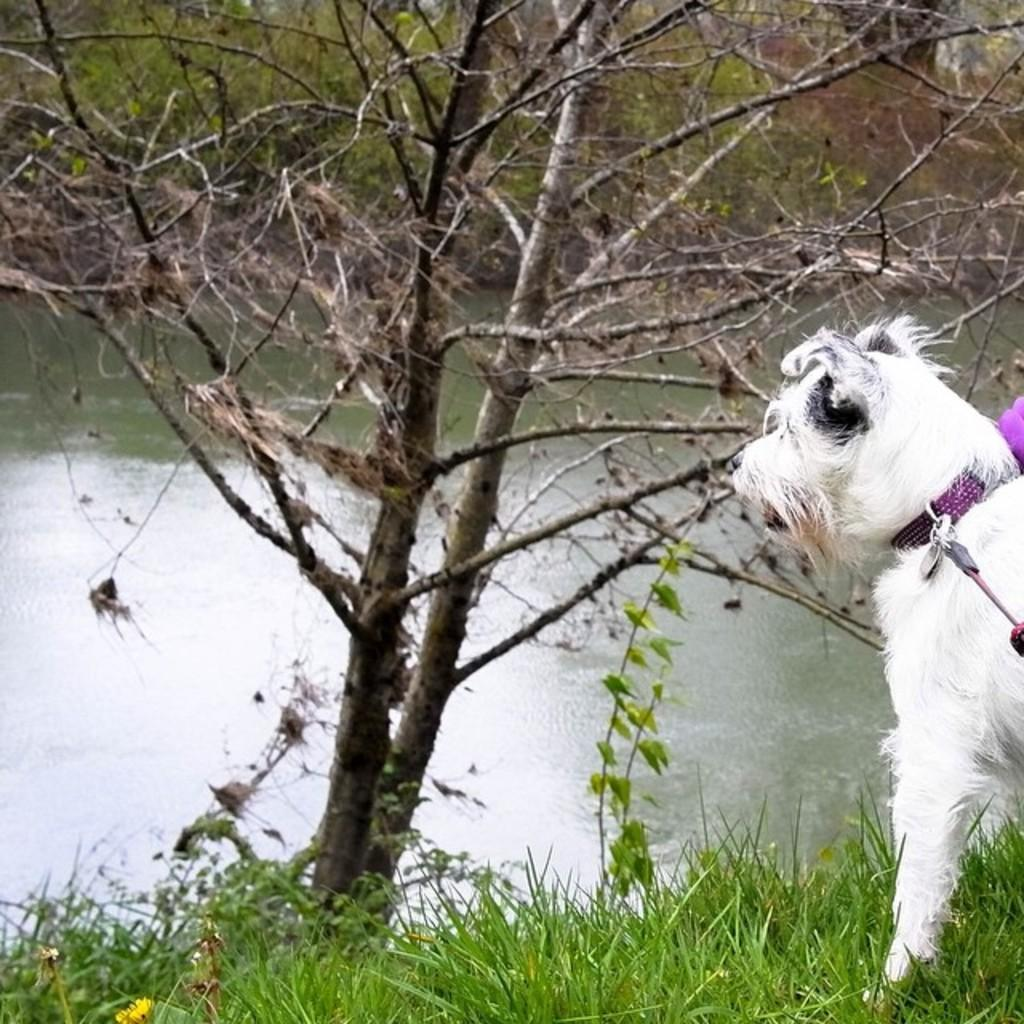What type of animal can be seen in the right corner of the image? There is a white dog in the right corner of the image. What is the main object in the middle of the image? There is a dry tree in the middle of the image. What can be seen in the background of the image? Pound water is visible in the background of the image. What type of joke is being told by the band in the image? There is no band present in the image, so no jokes are being told. Can you describe the iron used by the person in the image? There is no person or iron present in the image. 